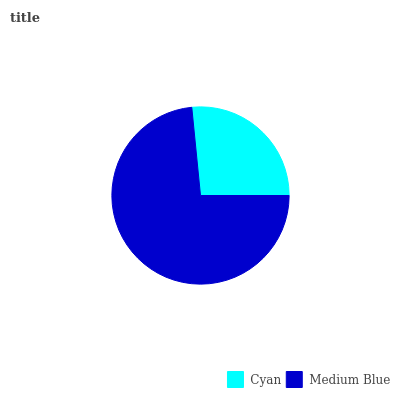Is Cyan the minimum?
Answer yes or no. Yes. Is Medium Blue the maximum?
Answer yes or no. Yes. Is Medium Blue the minimum?
Answer yes or no. No. Is Medium Blue greater than Cyan?
Answer yes or no. Yes. Is Cyan less than Medium Blue?
Answer yes or no. Yes. Is Cyan greater than Medium Blue?
Answer yes or no. No. Is Medium Blue less than Cyan?
Answer yes or no. No. Is Medium Blue the high median?
Answer yes or no. Yes. Is Cyan the low median?
Answer yes or no. Yes. Is Cyan the high median?
Answer yes or no. No. Is Medium Blue the low median?
Answer yes or no. No. 